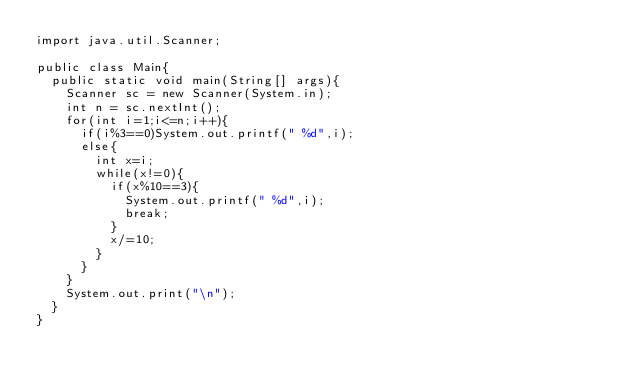<code> <loc_0><loc_0><loc_500><loc_500><_Java_>import java.util.Scanner;

public class Main{
	public static void main(String[] args){
		Scanner sc = new Scanner(System.in);
		int n = sc.nextInt();
		for(int i=1;i<=n;i++){
			if(i%3==0)System.out.printf(" %d",i);
			else{
				int x=i;
				while(x!=0){
					if(x%10==3){
						System.out.printf(" %d",i);
						break;
					}
					x/=10;
				}
			}
		}
		System.out.print("\n");
	}
}

</code> 